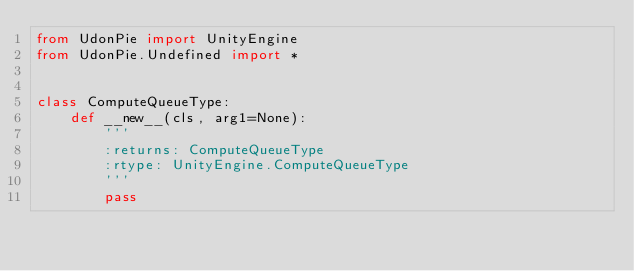<code> <loc_0><loc_0><loc_500><loc_500><_Python_>from UdonPie import UnityEngine
from UdonPie.Undefined import *


class ComputeQueueType:
    def __new__(cls, arg1=None):
        '''
        :returns: ComputeQueueType
        :rtype: UnityEngine.ComputeQueueType
        '''
        pass
</code> 